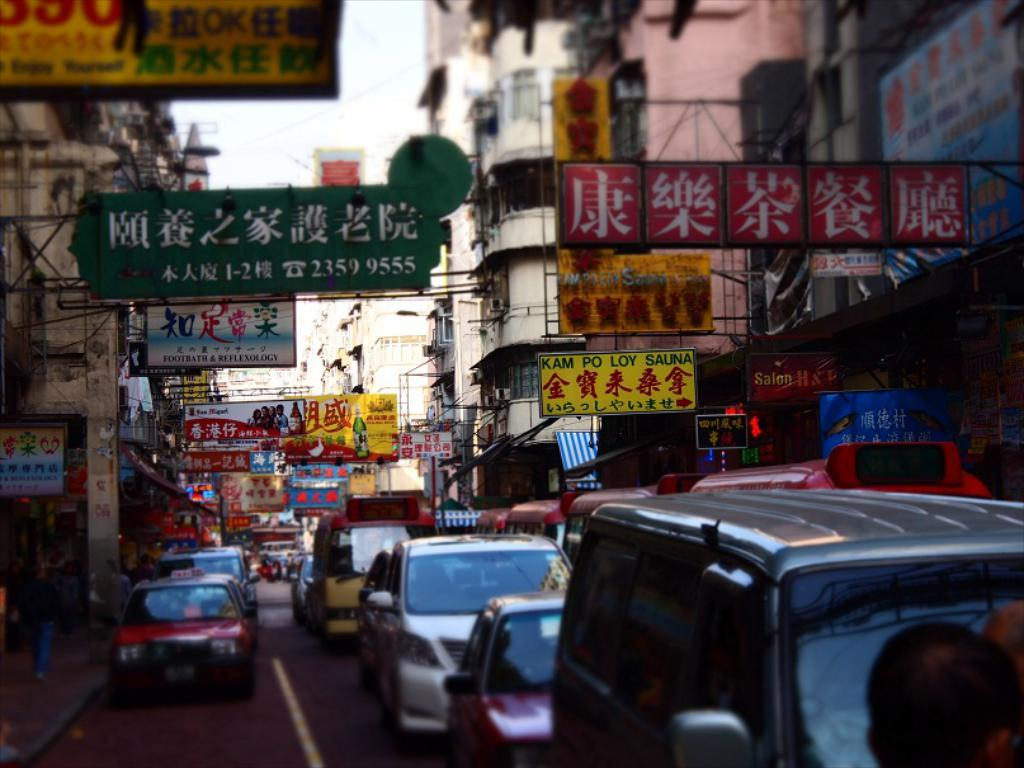<image>
Give a short and clear explanation of the subsequent image. some Japanese writing all over the stores around the street 